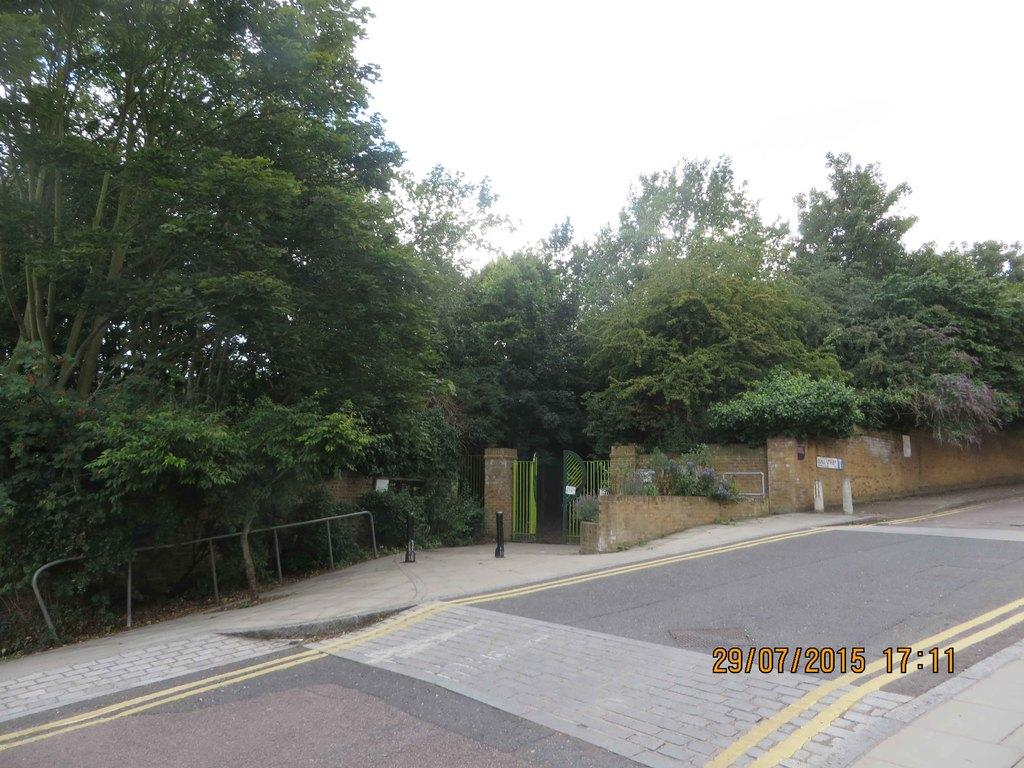What type of surface can be seen in the image? There is a road and a path in the image. What structures are present in the image? There are poles, a gate, and a wall in the image. What type of vegetation is visible in the image? There are trees and plants in the image. What part of the natural environment is visible in the image? The sky is visible in the image. What additional information is displayed in the image? The time and date are displayed in the bottom right corner of the image. Can you see the face of the parent in the image? There is no face or parent present in the image. What type of destruction is happening in the image? There is no destruction or any indication of it in the image. 